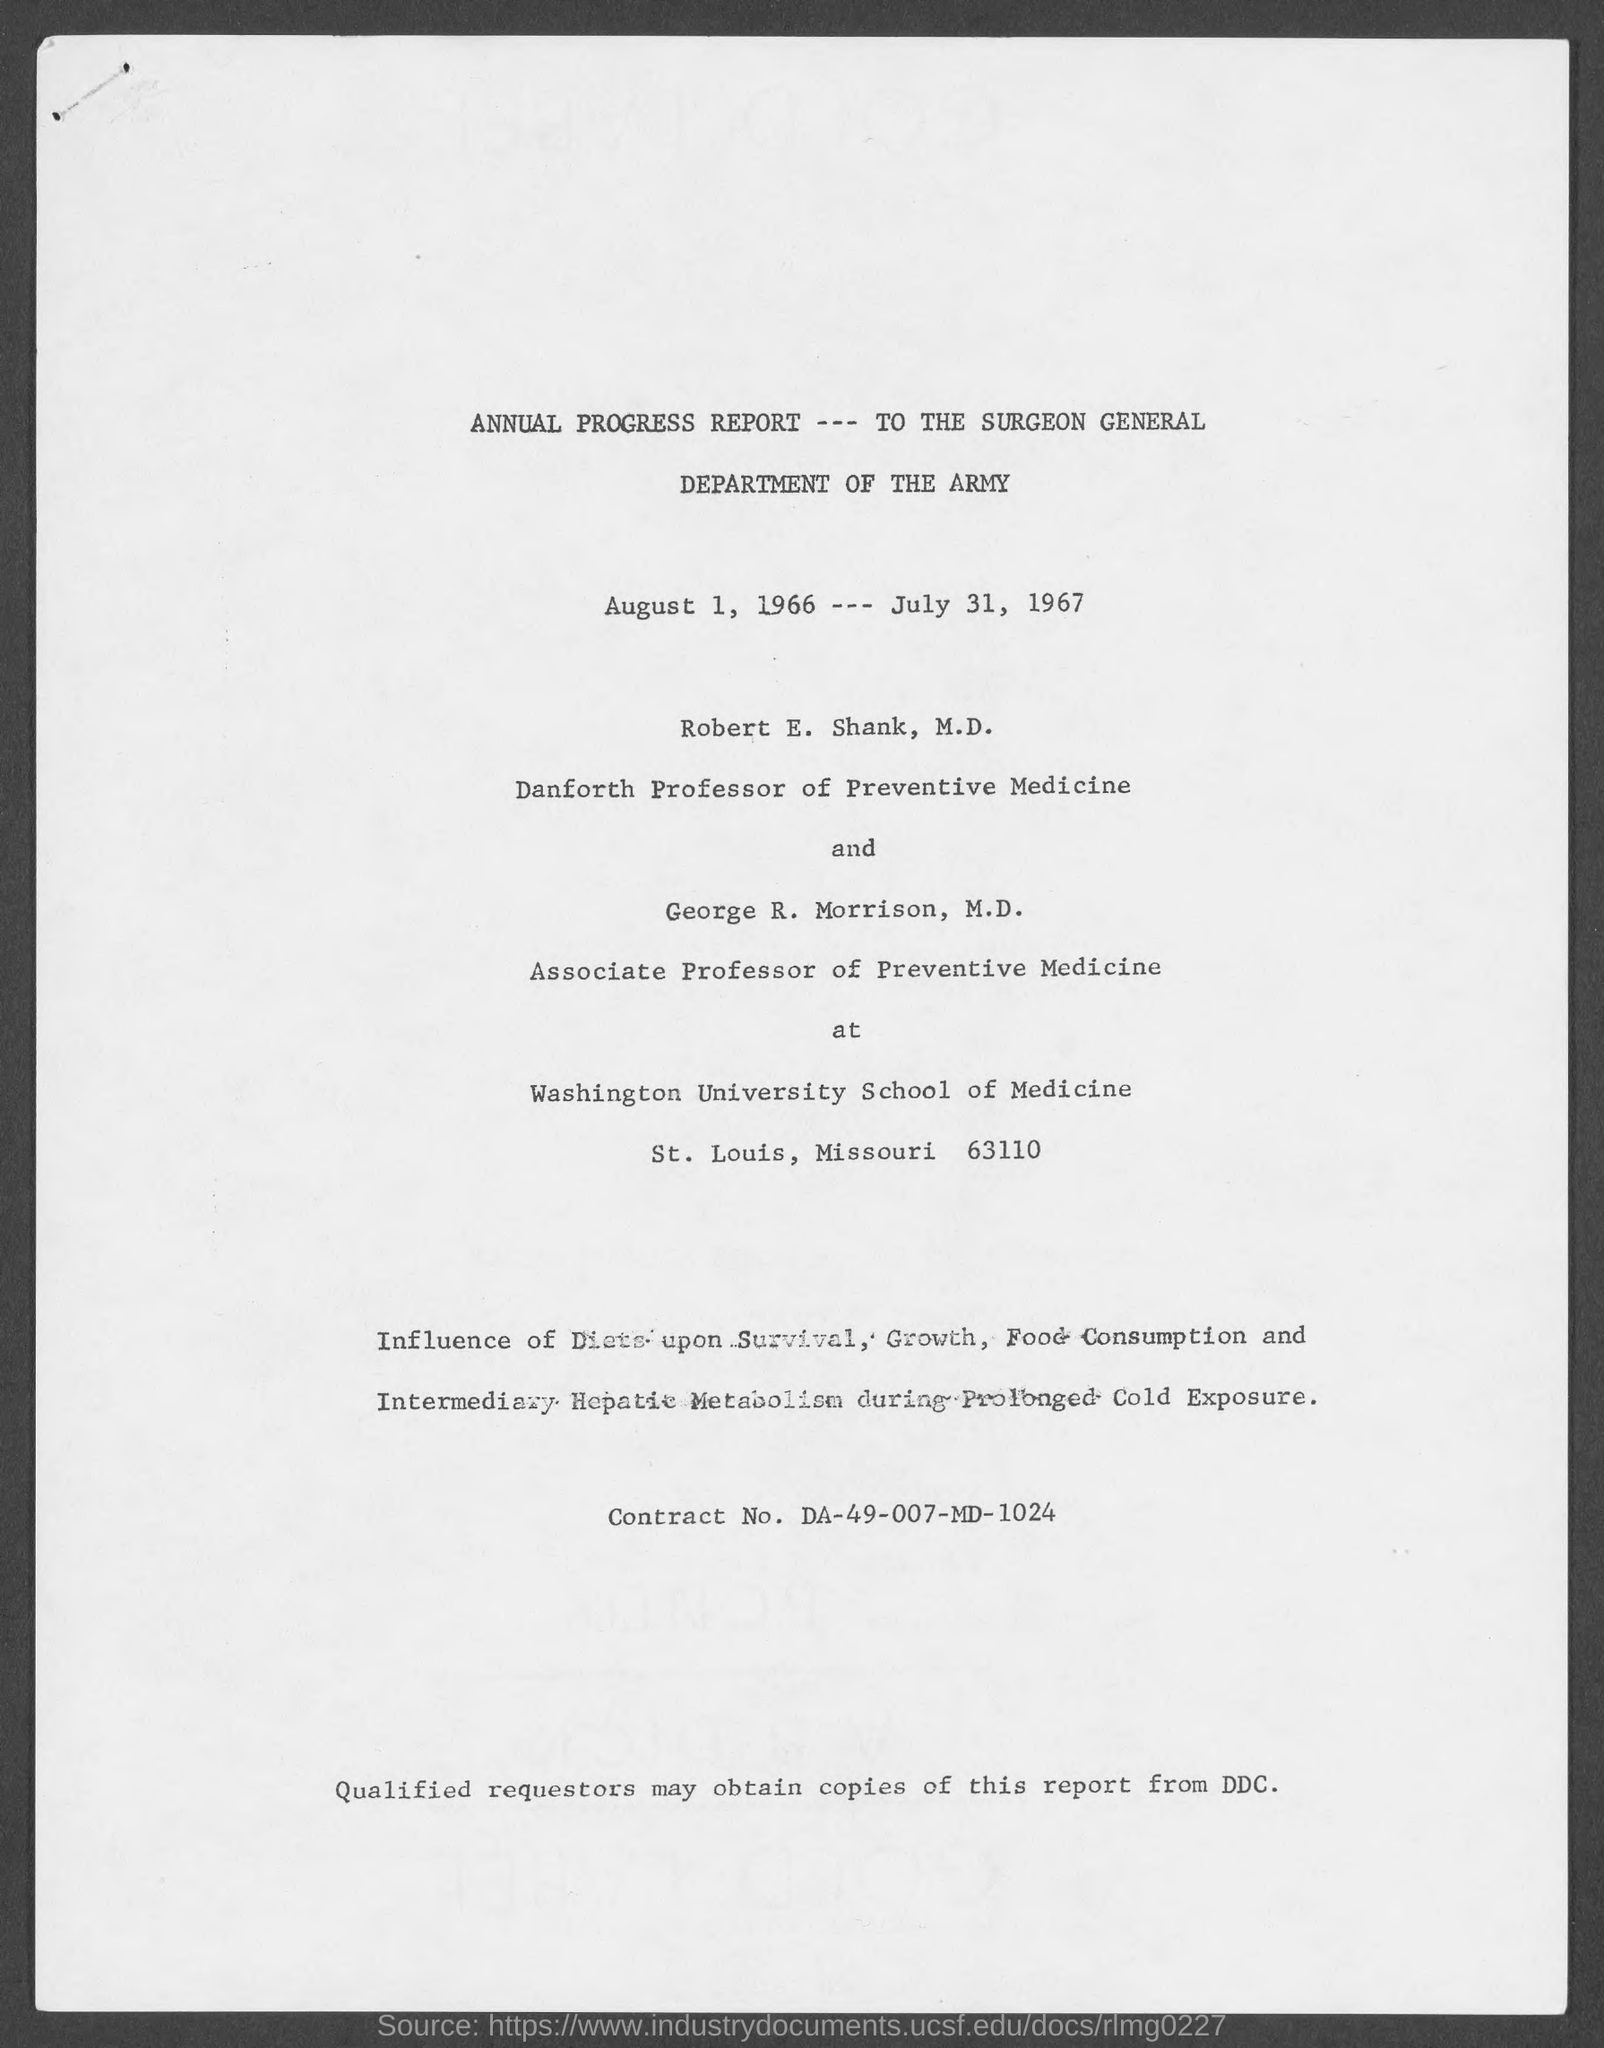Outline some significant characteristics in this image. The Washington University School of Medicine is located in St. Louis County. Robert E. Shank, M.D. holds the position of Danforth professor of preventive medicine. The contract number is DA-49-007-MD-1024. 